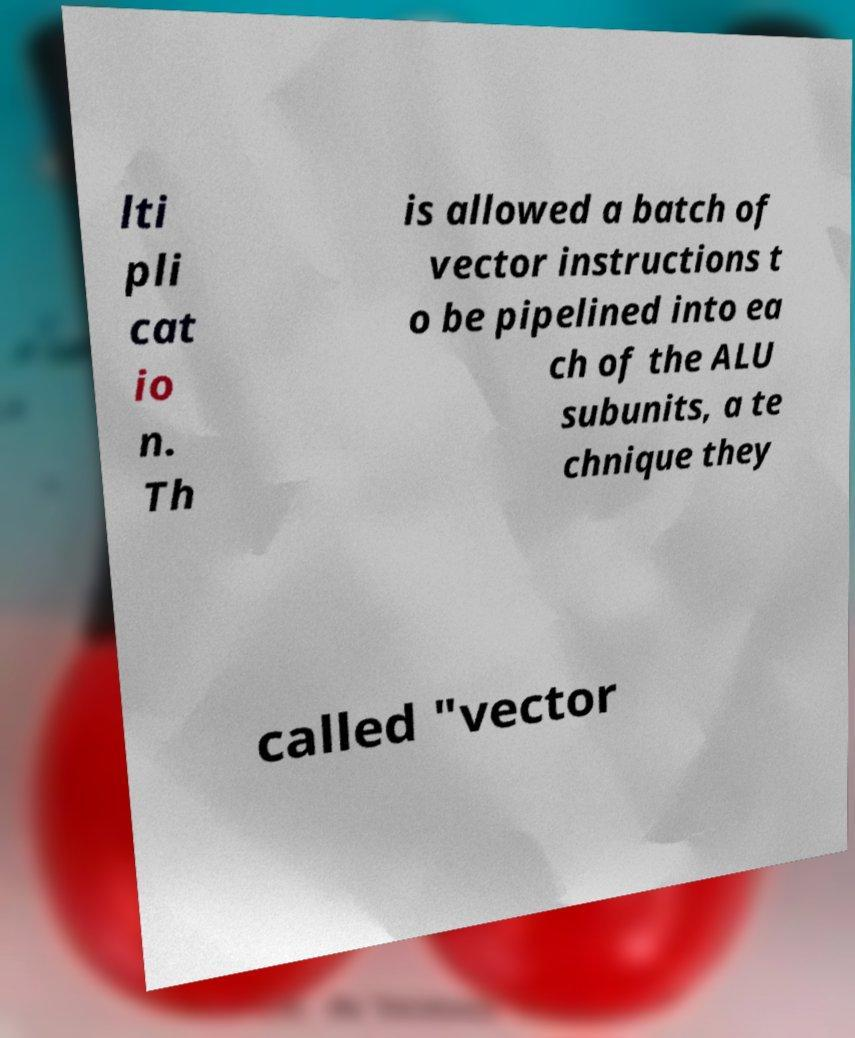I need the written content from this picture converted into text. Can you do that? lti pli cat io n. Th is allowed a batch of vector instructions t o be pipelined into ea ch of the ALU subunits, a te chnique they called "vector 